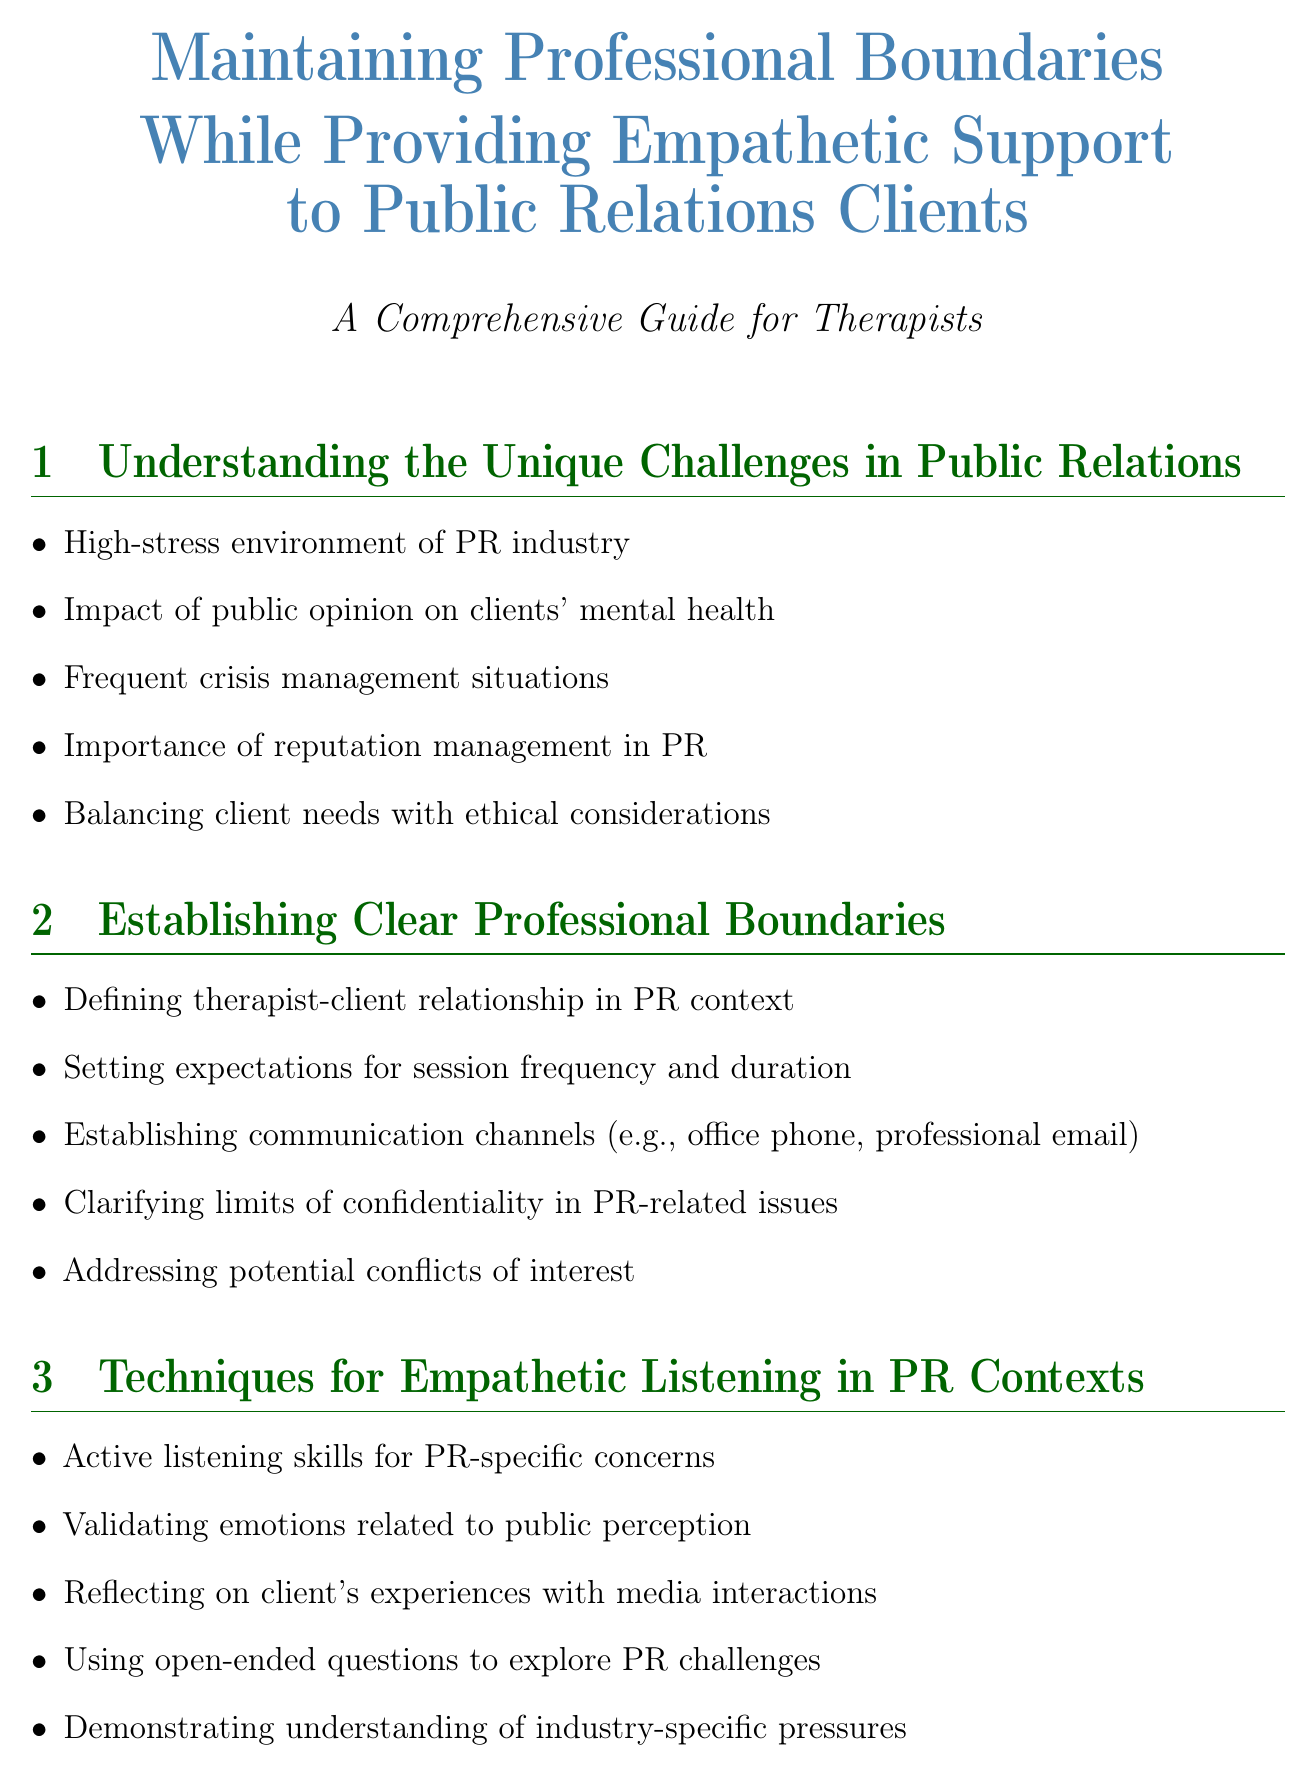What is the title of the document? The title is clearly stated in the document as the header, which is about maintaining professional boundaries while providing support to clients in the public relations industry.
Answer: Maintaining Professional Boundaries While Providing Empathetic Support to Public Relations Clients How many main sections are in the document? The sections are numbered in the document, and counting each section title reveals the total.
Answer: 10 What technique is emphasized for empathetic listening? The document lists specific skills under the Techniques for Empathetic Listening section, particularly highlighting one.
Answer: Active listening skills What is a self-care strategy mentioned for PR professionals? The document provides a list of self-care strategies and highlights techniques appropriate for PR professionals.
Answer: Mindfulness techniques What should therapists recognize to maintain ethical standards? Ethical considerations are discussed, emphasizing certain behaviors and practices for therapists in the document.
Answer: Dual relationships What is suggested for addressing signs of burnout? In the Crisis Intervention section, specific recommendations for therapists dealing with burnout among PR professionals are provided.
Answer: Identifying signs of burnout What network is recommended for PR professionals? The document mentions the importance of connections for support and guidance in their field.
Answer: Support network What do therapists need to stay updated on? The Continuing Education section outlines areas where therapists should continuously learn to remain effective.
Answer: PR industry trends and challenges How should confidentiality be maintained? The document addresses the importance of confidentiality, particularly in high-profile client situations and describes its management.
Answer: Client confidentiality 